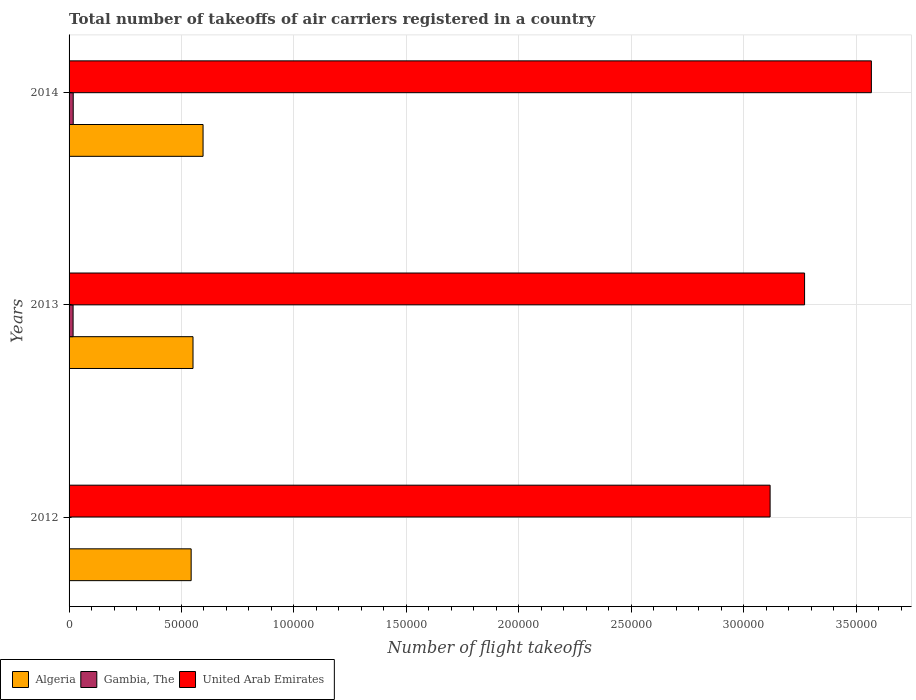How many groups of bars are there?
Give a very brief answer. 3. Are the number of bars per tick equal to the number of legend labels?
Offer a terse response. Yes. Are the number of bars on each tick of the Y-axis equal?
Make the answer very short. Yes. How many bars are there on the 2nd tick from the top?
Give a very brief answer. 3. What is the total number of flight takeoffs in Algeria in 2012?
Offer a terse response. 5.43e+04. Across all years, what is the maximum total number of flight takeoffs in Algeria?
Provide a succinct answer. 5.96e+04. Across all years, what is the minimum total number of flight takeoffs in United Arab Emirates?
Make the answer very short. 3.12e+05. In which year was the total number of flight takeoffs in Gambia, The maximum?
Your response must be concise. 2014. What is the total total number of flight takeoffs in Algeria in the graph?
Your answer should be compact. 1.69e+05. What is the difference between the total number of flight takeoffs in Gambia, The in 2012 and that in 2014?
Offer a terse response. -1702.67. What is the difference between the total number of flight takeoffs in United Arab Emirates in 2014 and the total number of flight takeoffs in Algeria in 2013?
Provide a succinct answer. 3.02e+05. What is the average total number of flight takeoffs in Gambia, The per year?
Provide a succinct answer. 1257.22. In the year 2013, what is the difference between the total number of flight takeoffs in Algeria and total number of flight takeoffs in Gambia, The?
Provide a short and direct response. 5.33e+04. In how many years, is the total number of flight takeoffs in United Arab Emirates greater than 200000 ?
Make the answer very short. 3. What is the ratio of the total number of flight takeoffs in Algeria in 2012 to that in 2014?
Keep it short and to the point. 0.91. Is the difference between the total number of flight takeoffs in Algeria in 2013 and 2014 greater than the difference between the total number of flight takeoffs in Gambia, The in 2013 and 2014?
Your answer should be compact. No. What is the difference between the highest and the second highest total number of flight takeoffs in Gambia, The?
Make the answer very short. 53.67. What is the difference between the highest and the lowest total number of flight takeoffs in United Arab Emirates?
Offer a terse response. 4.50e+04. Is the sum of the total number of flight takeoffs in Algeria in 2013 and 2014 greater than the maximum total number of flight takeoffs in Gambia, The across all years?
Provide a succinct answer. Yes. What does the 2nd bar from the top in 2013 represents?
Offer a terse response. Gambia, The. What does the 1st bar from the bottom in 2012 represents?
Keep it short and to the point. Algeria. How many years are there in the graph?
Give a very brief answer. 3. Are the values on the major ticks of X-axis written in scientific E-notation?
Offer a terse response. No. Does the graph contain any zero values?
Offer a terse response. No. Where does the legend appear in the graph?
Give a very brief answer. Bottom left. How many legend labels are there?
Provide a short and direct response. 3. How are the legend labels stacked?
Your response must be concise. Horizontal. What is the title of the graph?
Provide a succinct answer. Total number of takeoffs of air carriers registered in a country. What is the label or title of the X-axis?
Ensure brevity in your answer.  Number of flight takeoffs. What is the label or title of the Y-axis?
Ensure brevity in your answer.  Years. What is the Number of flight takeoffs of Algeria in 2012?
Offer a terse response. 5.43e+04. What is the Number of flight takeoffs in Gambia, The in 2012?
Your response must be concise. 140. What is the Number of flight takeoffs in United Arab Emirates in 2012?
Make the answer very short. 3.12e+05. What is the Number of flight takeoffs in Algeria in 2013?
Your response must be concise. 5.51e+04. What is the Number of flight takeoffs in Gambia, The in 2013?
Offer a terse response. 1789. What is the Number of flight takeoffs of United Arab Emirates in 2013?
Provide a succinct answer. 3.27e+05. What is the Number of flight takeoffs of Algeria in 2014?
Keep it short and to the point. 5.96e+04. What is the Number of flight takeoffs of Gambia, The in 2014?
Your answer should be compact. 1842.67. What is the Number of flight takeoffs of United Arab Emirates in 2014?
Offer a very short reply. 3.57e+05. Across all years, what is the maximum Number of flight takeoffs of Algeria?
Offer a very short reply. 5.96e+04. Across all years, what is the maximum Number of flight takeoffs of Gambia, The?
Make the answer very short. 1842.67. Across all years, what is the maximum Number of flight takeoffs of United Arab Emirates?
Give a very brief answer. 3.57e+05. Across all years, what is the minimum Number of flight takeoffs of Algeria?
Offer a very short reply. 5.43e+04. Across all years, what is the minimum Number of flight takeoffs in Gambia, The?
Keep it short and to the point. 140. Across all years, what is the minimum Number of flight takeoffs in United Arab Emirates?
Offer a terse response. 3.12e+05. What is the total Number of flight takeoffs in Algeria in the graph?
Ensure brevity in your answer.  1.69e+05. What is the total Number of flight takeoffs in Gambia, The in the graph?
Offer a very short reply. 3771.67. What is the total Number of flight takeoffs in United Arab Emirates in the graph?
Give a very brief answer. 9.96e+05. What is the difference between the Number of flight takeoffs of Algeria in 2012 and that in 2013?
Your answer should be very brief. -824. What is the difference between the Number of flight takeoffs in Gambia, The in 2012 and that in 2013?
Offer a very short reply. -1649. What is the difference between the Number of flight takeoffs in United Arab Emirates in 2012 and that in 2013?
Your answer should be compact. -1.53e+04. What is the difference between the Number of flight takeoffs of Algeria in 2012 and that in 2014?
Provide a succinct answer. -5296.2. What is the difference between the Number of flight takeoffs in Gambia, The in 2012 and that in 2014?
Keep it short and to the point. -1702.67. What is the difference between the Number of flight takeoffs of United Arab Emirates in 2012 and that in 2014?
Give a very brief answer. -4.50e+04. What is the difference between the Number of flight takeoffs in Algeria in 2013 and that in 2014?
Give a very brief answer. -4472.2. What is the difference between the Number of flight takeoffs in Gambia, The in 2013 and that in 2014?
Your response must be concise. -53.67. What is the difference between the Number of flight takeoffs of United Arab Emirates in 2013 and that in 2014?
Provide a short and direct response. -2.97e+04. What is the difference between the Number of flight takeoffs in Algeria in 2012 and the Number of flight takeoffs in Gambia, The in 2013?
Provide a short and direct response. 5.25e+04. What is the difference between the Number of flight takeoffs of Algeria in 2012 and the Number of flight takeoffs of United Arab Emirates in 2013?
Keep it short and to the point. -2.73e+05. What is the difference between the Number of flight takeoffs of Gambia, The in 2012 and the Number of flight takeoffs of United Arab Emirates in 2013?
Keep it short and to the point. -3.27e+05. What is the difference between the Number of flight takeoffs of Algeria in 2012 and the Number of flight takeoffs of Gambia, The in 2014?
Provide a short and direct response. 5.24e+04. What is the difference between the Number of flight takeoffs of Algeria in 2012 and the Number of flight takeoffs of United Arab Emirates in 2014?
Make the answer very short. -3.03e+05. What is the difference between the Number of flight takeoffs of Gambia, The in 2012 and the Number of flight takeoffs of United Arab Emirates in 2014?
Offer a very short reply. -3.57e+05. What is the difference between the Number of flight takeoffs in Algeria in 2013 and the Number of flight takeoffs in Gambia, The in 2014?
Give a very brief answer. 5.33e+04. What is the difference between the Number of flight takeoffs of Algeria in 2013 and the Number of flight takeoffs of United Arab Emirates in 2014?
Provide a short and direct response. -3.02e+05. What is the difference between the Number of flight takeoffs of Gambia, The in 2013 and the Number of flight takeoffs of United Arab Emirates in 2014?
Offer a terse response. -3.55e+05. What is the average Number of flight takeoffs in Algeria per year?
Your answer should be very brief. 5.63e+04. What is the average Number of flight takeoffs in Gambia, The per year?
Provide a short and direct response. 1257.22. What is the average Number of flight takeoffs in United Arab Emirates per year?
Offer a terse response. 3.32e+05. In the year 2012, what is the difference between the Number of flight takeoffs in Algeria and Number of flight takeoffs in Gambia, The?
Provide a short and direct response. 5.42e+04. In the year 2012, what is the difference between the Number of flight takeoffs in Algeria and Number of flight takeoffs in United Arab Emirates?
Provide a succinct answer. -2.57e+05. In the year 2012, what is the difference between the Number of flight takeoffs in Gambia, The and Number of flight takeoffs in United Arab Emirates?
Your answer should be compact. -3.12e+05. In the year 2013, what is the difference between the Number of flight takeoffs of Algeria and Number of flight takeoffs of Gambia, The?
Give a very brief answer. 5.33e+04. In the year 2013, what is the difference between the Number of flight takeoffs of Algeria and Number of flight takeoffs of United Arab Emirates?
Offer a very short reply. -2.72e+05. In the year 2013, what is the difference between the Number of flight takeoffs of Gambia, The and Number of flight takeoffs of United Arab Emirates?
Make the answer very short. -3.25e+05. In the year 2014, what is the difference between the Number of flight takeoffs in Algeria and Number of flight takeoffs in Gambia, The?
Ensure brevity in your answer.  5.77e+04. In the year 2014, what is the difference between the Number of flight takeoffs of Algeria and Number of flight takeoffs of United Arab Emirates?
Keep it short and to the point. -2.97e+05. In the year 2014, what is the difference between the Number of flight takeoffs of Gambia, The and Number of flight takeoffs of United Arab Emirates?
Your response must be concise. -3.55e+05. What is the ratio of the Number of flight takeoffs in Algeria in 2012 to that in 2013?
Make the answer very short. 0.98. What is the ratio of the Number of flight takeoffs of Gambia, The in 2012 to that in 2013?
Your answer should be compact. 0.08. What is the ratio of the Number of flight takeoffs in United Arab Emirates in 2012 to that in 2013?
Give a very brief answer. 0.95. What is the ratio of the Number of flight takeoffs in Algeria in 2012 to that in 2014?
Offer a very short reply. 0.91. What is the ratio of the Number of flight takeoffs in Gambia, The in 2012 to that in 2014?
Ensure brevity in your answer.  0.08. What is the ratio of the Number of flight takeoffs in United Arab Emirates in 2012 to that in 2014?
Make the answer very short. 0.87. What is the ratio of the Number of flight takeoffs in Algeria in 2013 to that in 2014?
Provide a succinct answer. 0.92. What is the ratio of the Number of flight takeoffs of Gambia, The in 2013 to that in 2014?
Your response must be concise. 0.97. What is the ratio of the Number of flight takeoffs of United Arab Emirates in 2013 to that in 2014?
Your answer should be very brief. 0.92. What is the difference between the highest and the second highest Number of flight takeoffs of Algeria?
Offer a terse response. 4472.2. What is the difference between the highest and the second highest Number of flight takeoffs in Gambia, The?
Provide a succinct answer. 53.67. What is the difference between the highest and the second highest Number of flight takeoffs in United Arab Emirates?
Offer a terse response. 2.97e+04. What is the difference between the highest and the lowest Number of flight takeoffs in Algeria?
Your answer should be very brief. 5296.2. What is the difference between the highest and the lowest Number of flight takeoffs in Gambia, The?
Make the answer very short. 1702.67. What is the difference between the highest and the lowest Number of flight takeoffs in United Arab Emirates?
Offer a very short reply. 4.50e+04. 